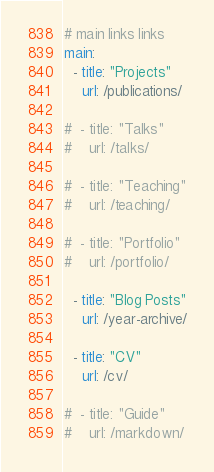Convert code to text. <code><loc_0><loc_0><loc_500><loc_500><_YAML_># main links links
main:
  - title: "Projects"
    url: /publications/

#  - title: "Talks"
#    url: /talks/    

#  - title: "Teaching"
#    url: /teaching/    
    
#  - title: "Portfolio"
#    url: /portfolio/
        
  - title: "Blog Posts"
    url: /year-archive/
    
  - title: "CV"
    url: /cv/
    
#  - title: "Guide"
#    url: /markdown/
</code> 